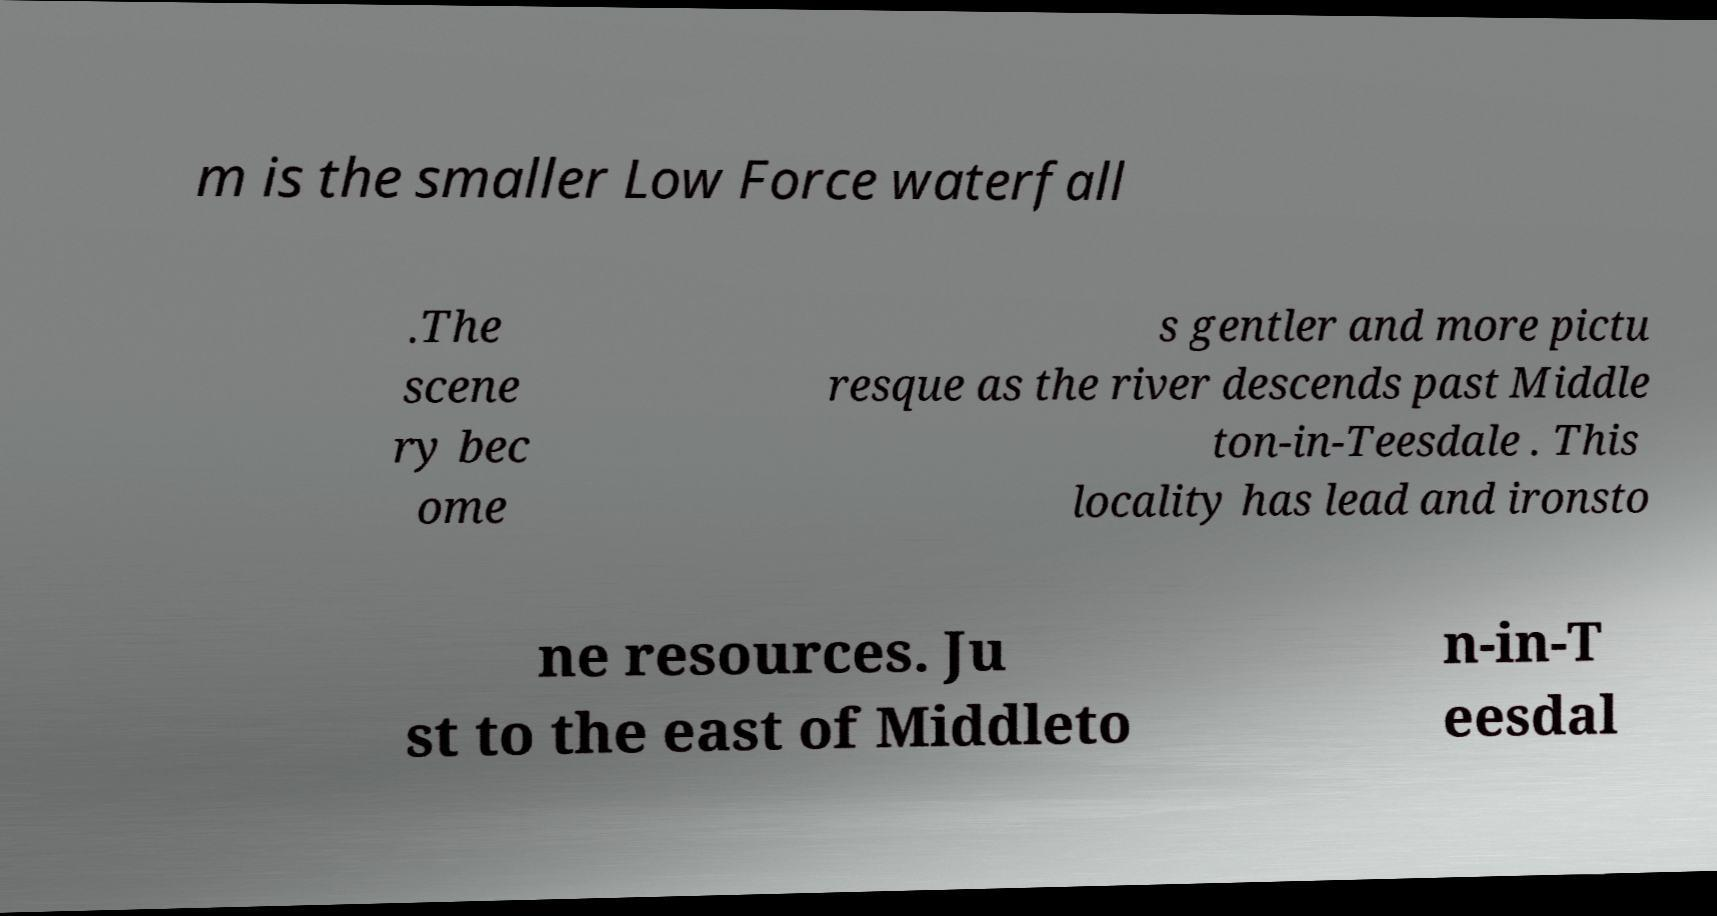For documentation purposes, I need the text within this image transcribed. Could you provide that? m is the smaller Low Force waterfall .The scene ry bec ome s gentler and more pictu resque as the river descends past Middle ton-in-Teesdale . This locality has lead and ironsto ne resources. Ju st to the east of Middleto n-in-T eesdal 